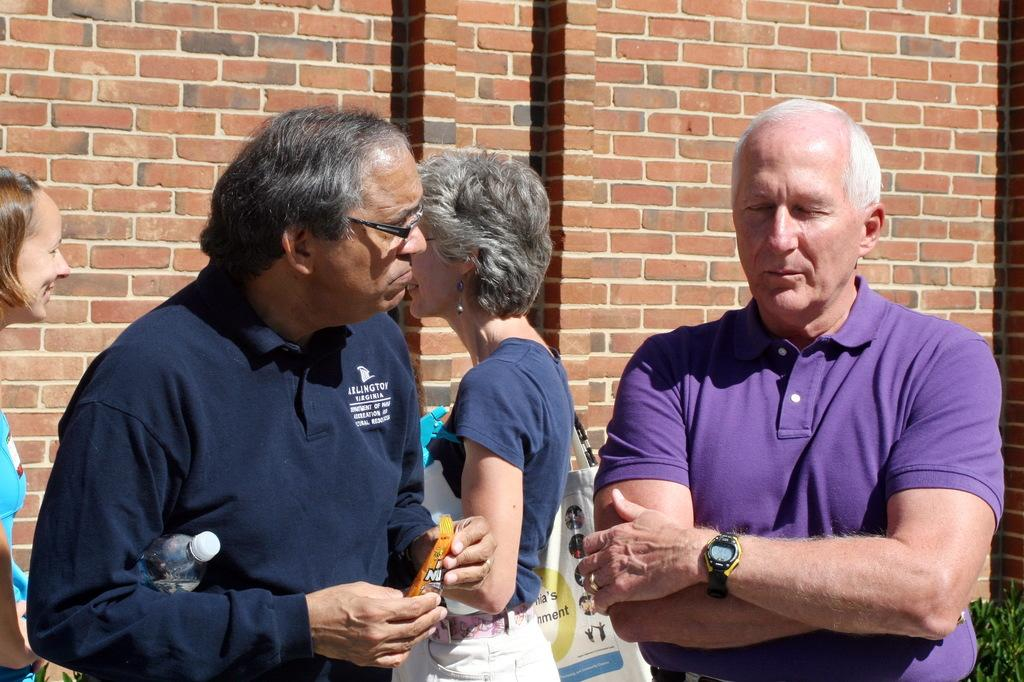What is happening in the image? There are people standing in the image. Can you describe the woman in the image? The woman is holding a bottle and carrying a bag in the image. What can be seen in the background of the image? There is a wall and leaves in the background of the image. What type of bulb is the woman holding in the image? There is no bulb present in the image; the woman is holding a bottle. How does the parcel affect the people standing in the image? There is no parcel mentioned in the image; the focus is on the woman holding a bottle and carrying a bag. 